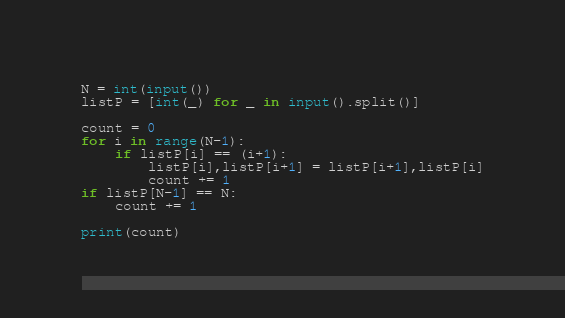Convert code to text. <code><loc_0><loc_0><loc_500><loc_500><_Python_>N = int(input())
listP = [int(_) for _ in input().split()]

count = 0
for i in range(N-1):
    if listP[i] == (i+1):
        listP[i],listP[i+1] = listP[i+1],listP[i]
        count += 1
if listP[N-1] == N:
    count += 1

print(count)
</code> 